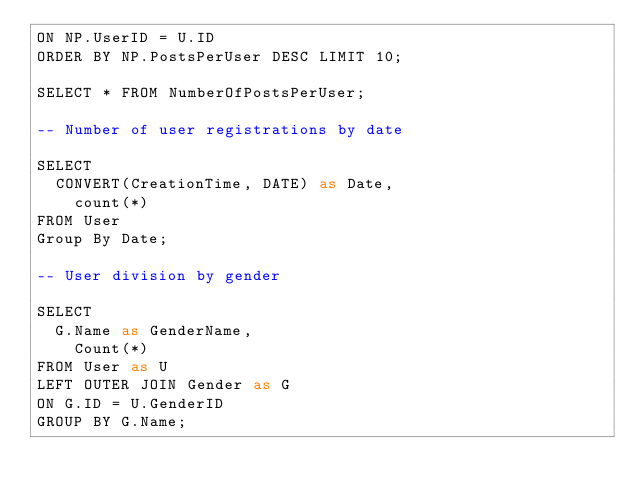<code> <loc_0><loc_0><loc_500><loc_500><_SQL_>ON NP.UserID = U.ID
ORDER BY NP.PostsPerUser DESC LIMIT 10;

SELECT * FROM NumberOfPostsPerUser;

-- Number of user registrations by date

SELECT 
	CONVERT(CreationTime, DATE) as Date,
    count(*)
FROM User
Group By Date;

-- User division by gender

SELECT
	G.Name as GenderName,
    Count(*)
FROM User as U
LEFT OUTER JOIN Gender as G
ON G.ID = U.GenderID
GROUP BY G.Name;
    
    
    
    

</code> 